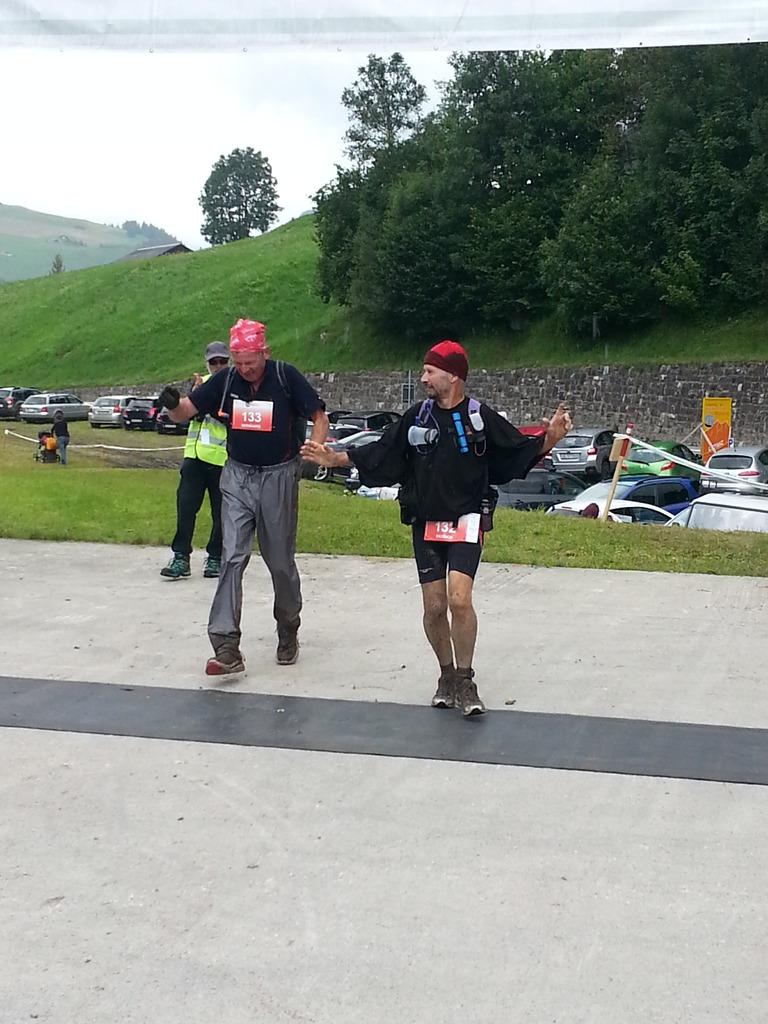What is happening on the road in the image? There are people on the road in the image. What is behind the people on-people on the road? There are vehicles behind the people on the road. Where are other people located in the image? There are people on the grass in the image. What type of vegetation is around the people on the grass? Grass is visible around the people on the grass. What natural elements can be seen in the image? Trees are present in the image. What type of structure is visible in the image? There is a brick wall in the image. What type of cherry is being used as a prop on the stage in the image? There is no stage or cherry present in the image. What type of furniture can be seen in the bedroom in the image? There is no bedroom present in the image. 